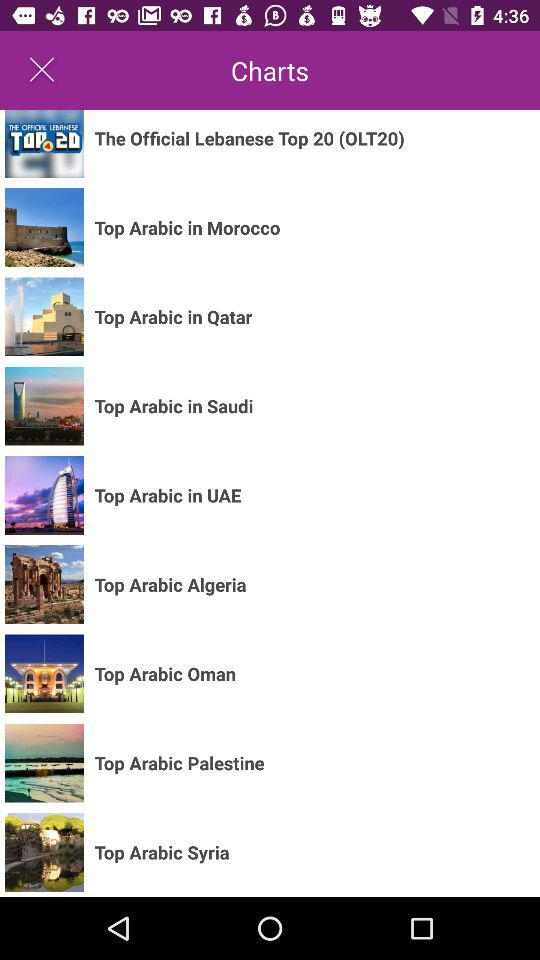How many countries have Top Arabic charts?
Answer the question using a single word or phrase. 8 